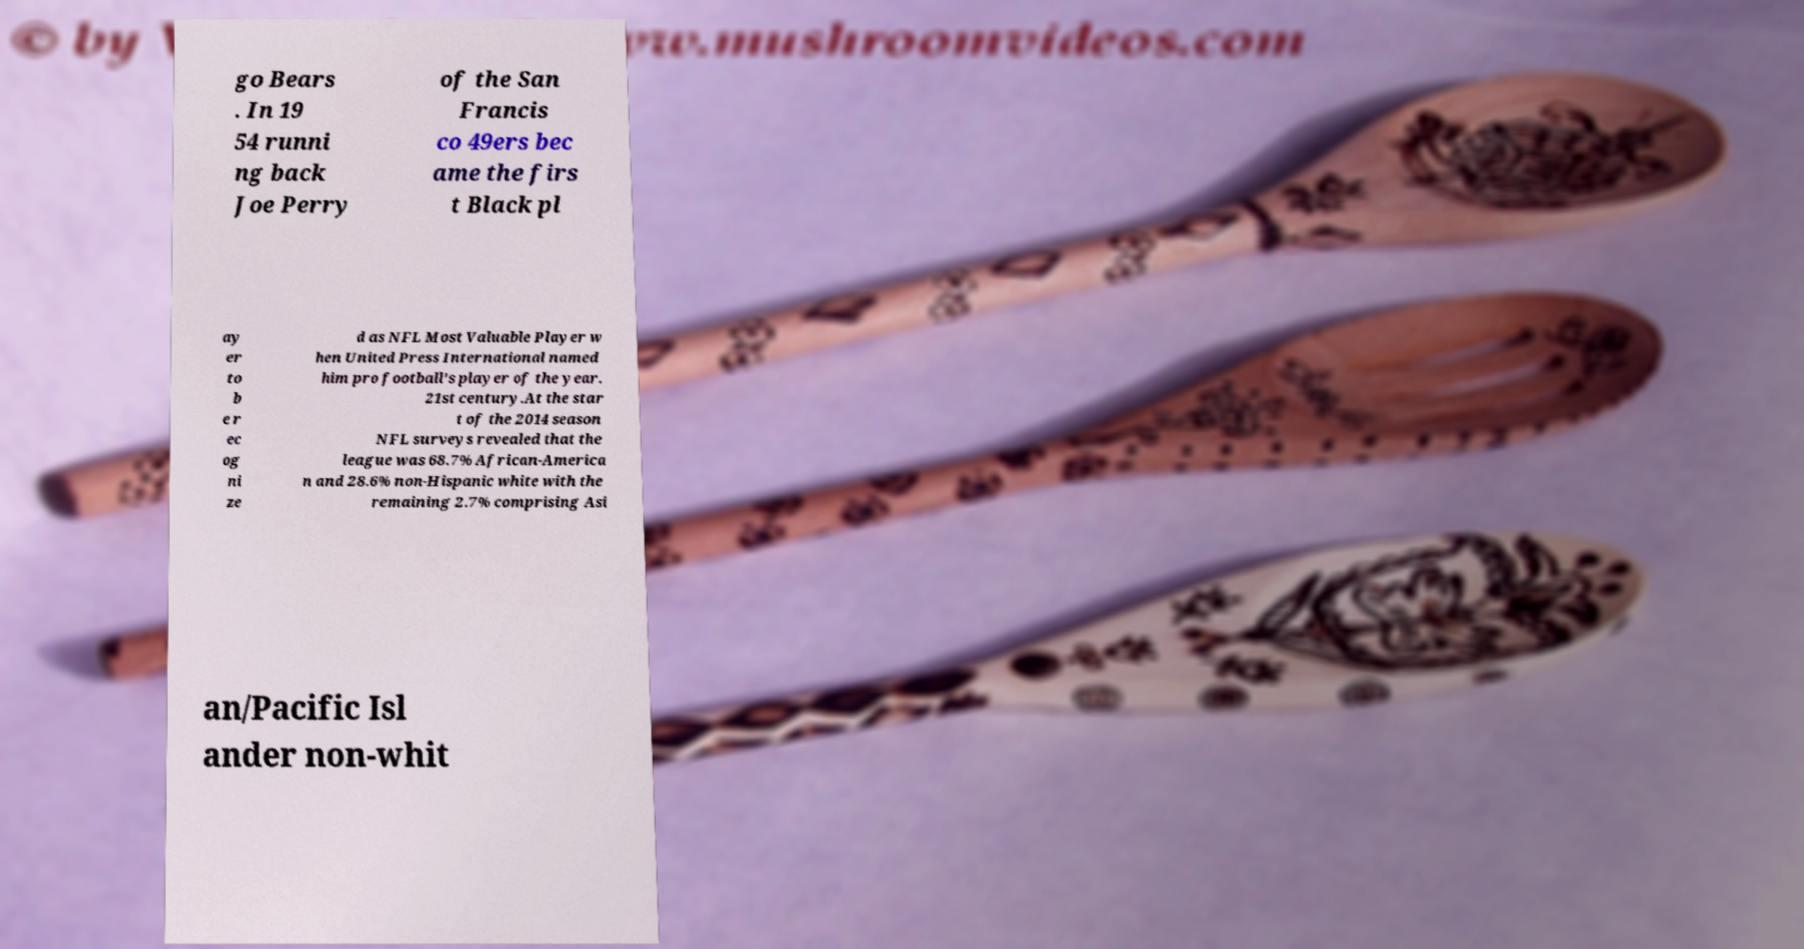Can you accurately transcribe the text from the provided image for me? go Bears . In 19 54 runni ng back Joe Perry of the San Francis co 49ers bec ame the firs t Black pl ay er to b e r ec og ni ze d as NFL Most Valuable Player w hen United Press International named him pro football's player of the year. 21st century.At the star t of the 2014 season NFL surveys revealed that the league was 68.7% African-America n and 28.6% non-Hispanic white with the remaining 2.7% comprising Asi an/Pacific Isl ander non-whit 